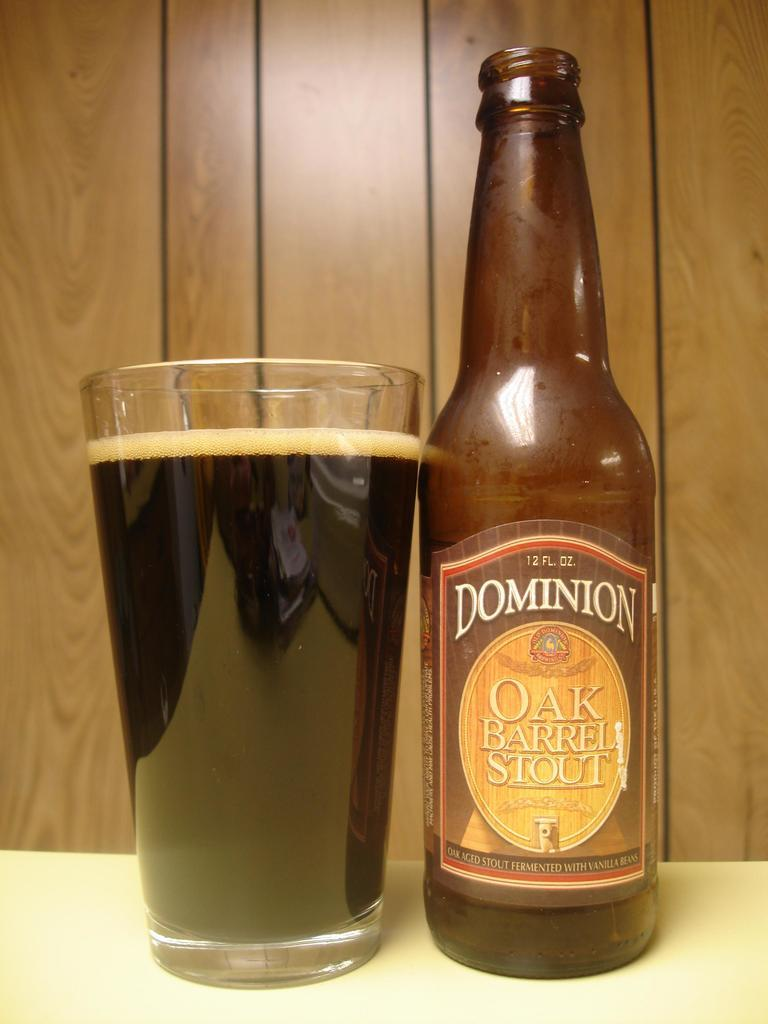<image>
Describe the image concisely. a bottle of dominion oak barrel stout next to a glass full of it 